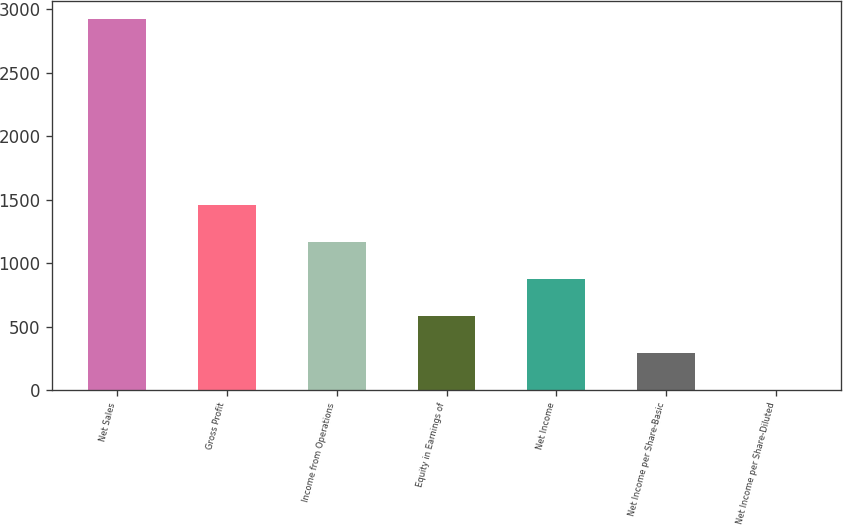<chart> <loc_0><loc_0><loc_500><loc_500><bar_chart><fcel>Net Sales<fcel>Gross Profit<fcel>Income from Operations<fcel>Equity in Earnings of<fcel>Net Income<fcel>Net Income per Share-Basic<fcel>Net Income per Share-Diluted<nl><fcel>2921.9<fcel>1462.18<fcel>1170.24<fcel>586.35<fcel>878.3<fcel>294.4<fcel>2.45<nl></chart> 